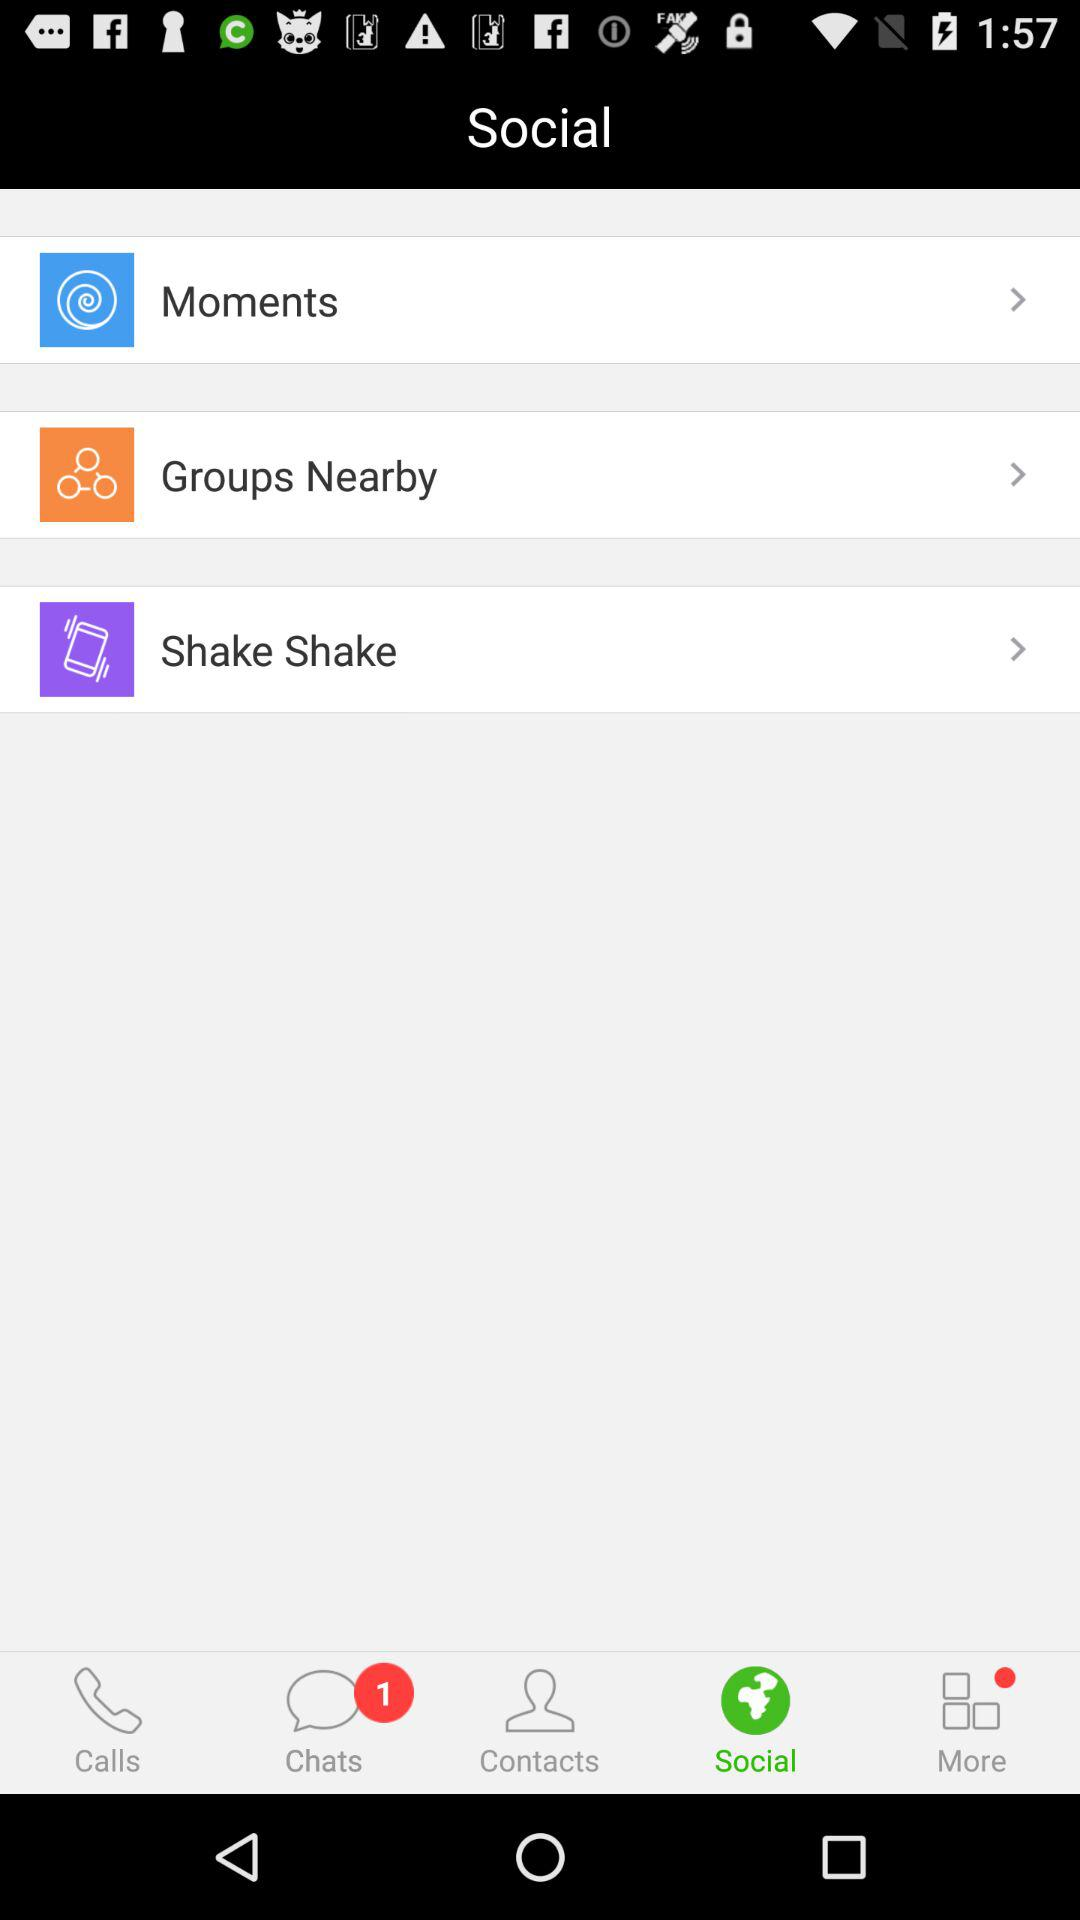How many unread chats are there? There is 1 unread chat. 